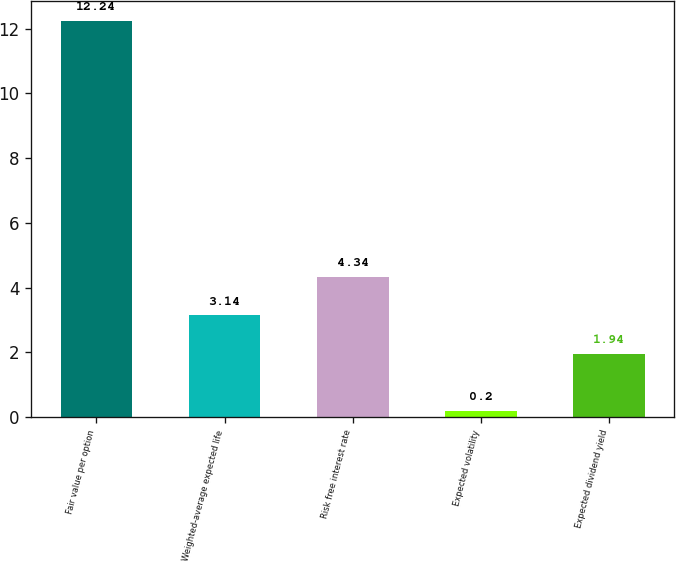<chart> <loc_0><loc_0><loc_500><loc_500><bar_chart><fcel>Fair value per option<fcel>Weighted-average expected life<fcel>Risk free interest rate<fcel>Expected volatility<fcel>Expected dividend yield<nl><fcel>12.24<fcel>3.14<fcel>4.34<fcel>0.2<fcel>1.94<nl></chart> 